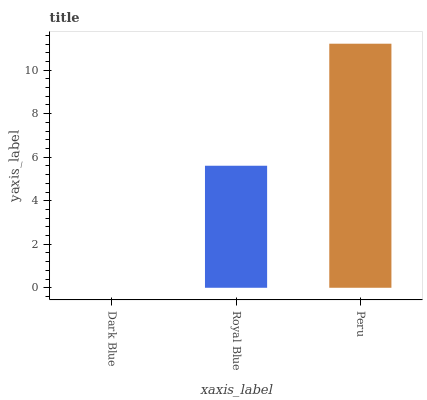Is Dark Blue the minimum?
Answer yes or no. Yes. Is Peru the maximum?
Answer yes or no. Yes. Is Royal Blue the minimum?
Answer yes or no. No. Is Royal Blue the maximum?
Answer yes or no. No. Is Royal Blue greater than Dark Blue?
Answer yes or no. Yes. Is Dark Blue less than Royal Blue?
Answer yes or no. Yes. Is Dark Blue greater than Royal Blue?
Answer yes or no. No. Is Royal Blue less than Dark Blue?
Answer yes or no. No. Is Royal Blue the high median?
Answer yes or no. Yes. Is Royal Blue the low median?
Answer yes or no. Yes. Is Peru the high median?
Answer yes or no. No. Is Dark Blue the low median?
Answer yes or no. No. 